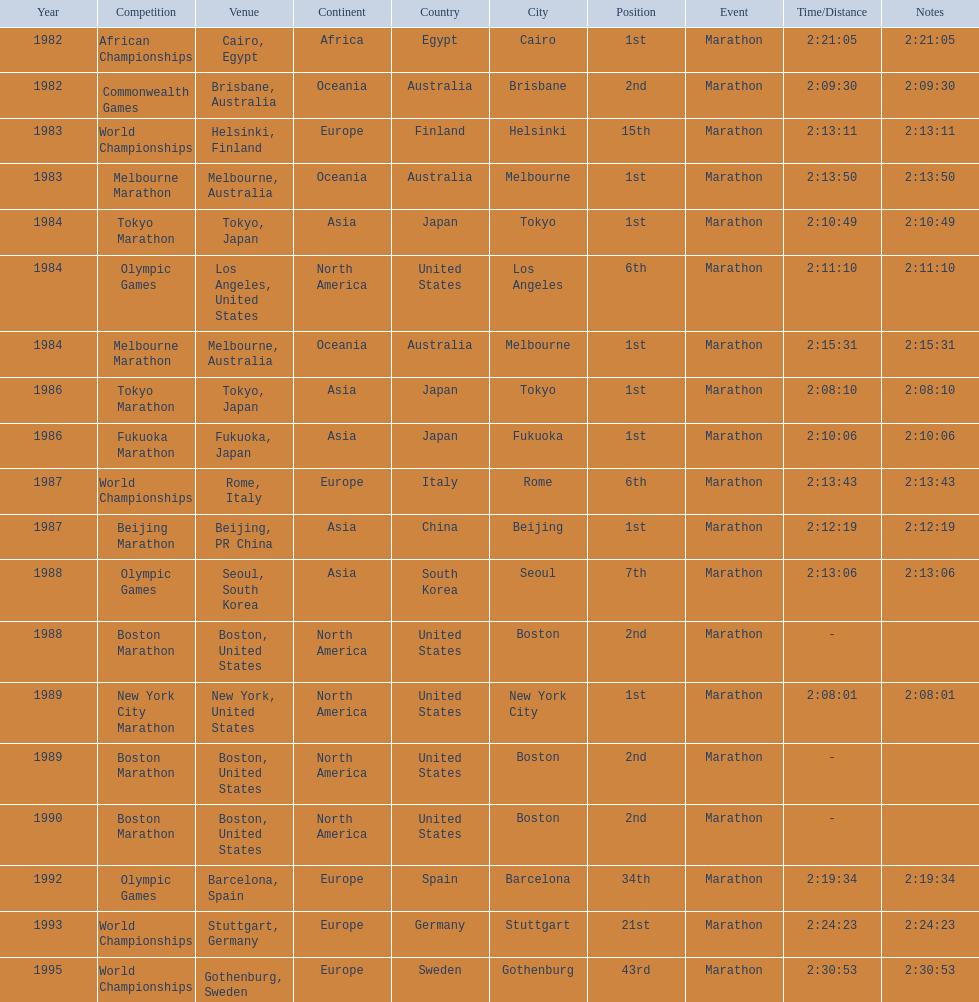What are all of the juma ikangaa competitions? African Championships, Commonwealth Games, World Championships, Melbourne Marathon, Tokyo Marathon, Olympic Games, Melbourne Marathon, Tokyo Marathon, Fukuoka Marathon, World Championships, Beijing Marathon, Olympic Games, Boston Marathon, New York City Marathon, Boston Marathon, Boston Marathon, Olympic Games, World Championships, World Championships. Which of these competitions did not take place in the united states? African Championships, Commonwealth Games, World Championships, Melbourne Marathon, Tokyo Marathon, Melbourne Marathon, Tokyo Marathon, Fukuoka Marathon, World Championships, Beijing Marathon, Olympic Games, Olympic Games, World Championships, World Championships. Out of these, which of them took place in asia? Tokyo Marathon, Tokyo Marathon, Fukuoka Marathon, Beijing Marathon, Olympic Games. Which of the remaining competitions took place in china? Beijing Marathon. 